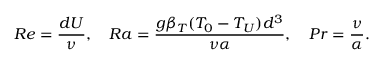Convert formula to latex. <formula><loc_0><loc_0><loc_500><loc_500>R e = \frac { d U } { \nu } , \quad R a = \frac { g \beta _ { T } ( T _ { 0 } - T _ { U } ) d ^ { 3 } } { \nu \alpha } , \quad P r = \frac { \nu } { \alpha } .</formula> 